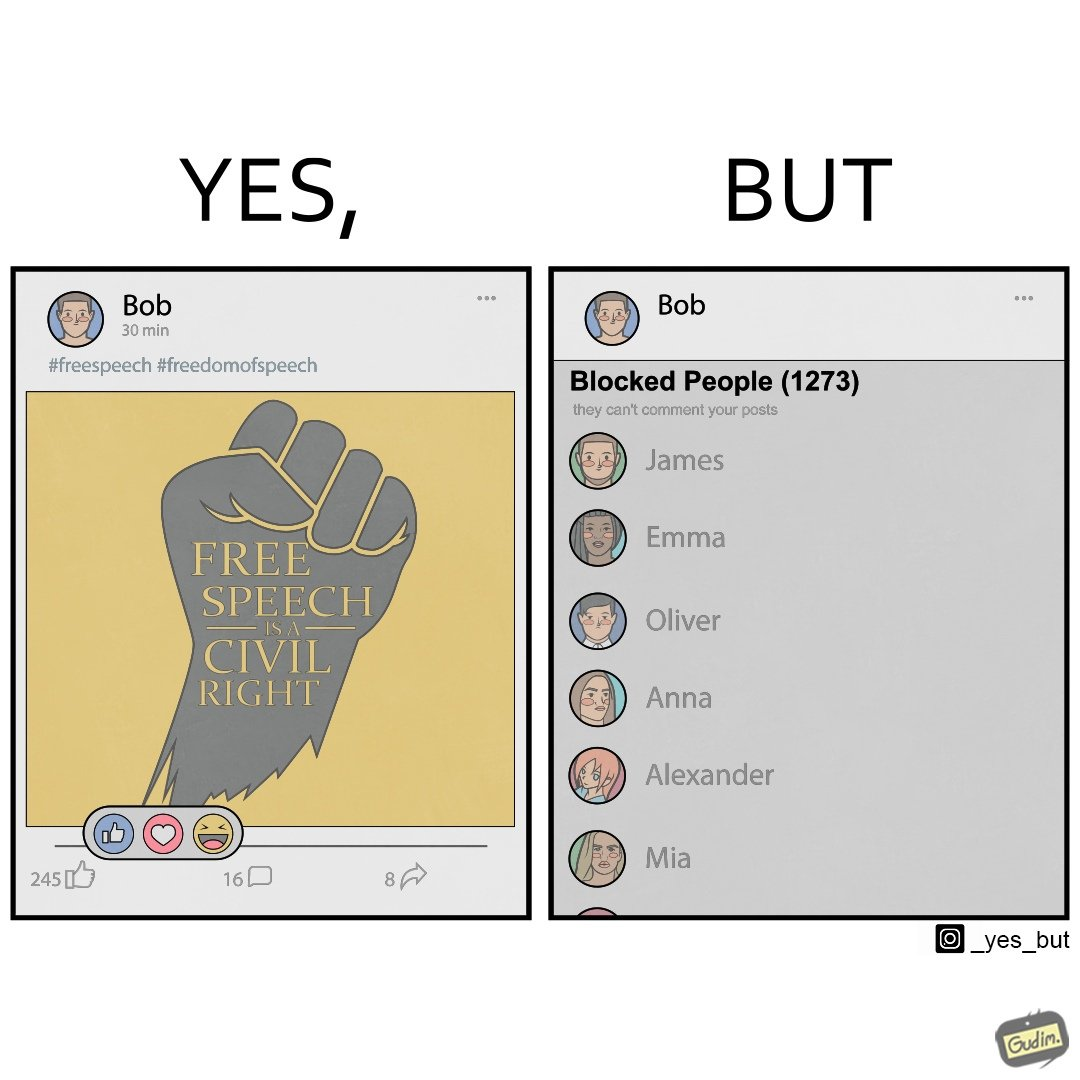Why is this image considered satirical? The images are funny since even though someone like "Bob" shows support for free speech as a civil right, he is not ready to deal with the consequences of free speech and chooses to not be spoken to by certain people. He thus blocks people from contacting him on his phone. 